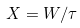Convert formula to latex. <formula><loc_0><loc_0><loc_500><loc_500>X = W / \tau</formula> 